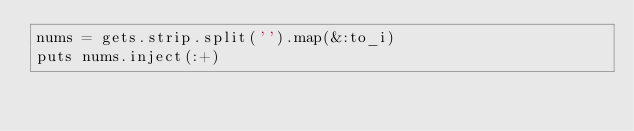<code> <loc_0><loc_0><loc_500><loc_500><_Ruby_>nums = gets.strip.split('').map(&:to_i)
puts nums.inject(:+)</code> 